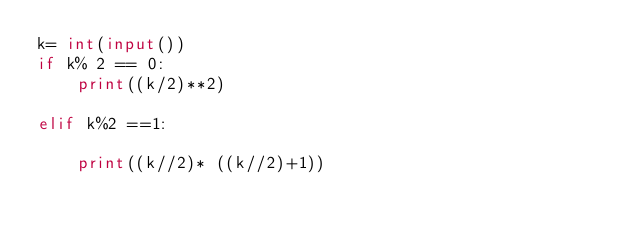<code> <loc_0><loc_0><loc_500><loc_500><_Python_>k= int(input())
if k% 2 == 0:
    print((k/2)**2)

elif k%2 ==1:

    print((k//2)* ((k//2)+1))</code> 